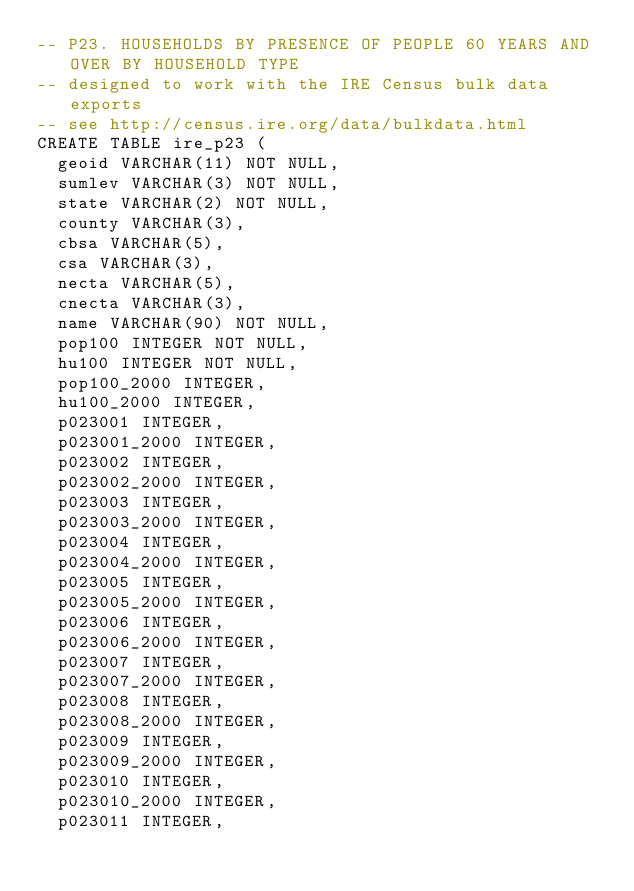<code> <loc_0><loc_0><loc_500><loc_500><_SQL_>-- P23. HOUSEHOLDS BY PRESENCE OF PEOPLE 60 YEARS AND OVER BY HOUSEHOLD TYPE
-- designed to work with the IRE Census bulk data exports
-- see http://census.ire.org/data/bulkdata.html
CREATE TABLE ire_p23 (
	geoid VARCHAR(11) NOT NULL, 
	sumlev VARCHAR(3) NOT NULL, 
	state VARCHAR(2) NOT NULL, 
	county VARCHAR(3), 
	cbsa VARCHAR(5), 
	csa VARCHAR(3), 
	necta VARCHAR(5), 
	cnecta VARCHAR(3), 
	name VARCHAR(90) NOT NULL, 
	pop100 INTEGER NOT NULL, 
	hu100 INTEGER NOT NULL, 
	pop100_2000 INTEGER, 
	hu100_2000 INTEGER, 
	p023001 INTEGER, 
	p023001_2000 INTEGER, 
	p023002 INTEGER, 
	p023002_2000 INTEGER, 
	p023003 INTEGER, 
	p023003_2000 INTEGER, 
	p023004 INTEGER, 
	p023004_2000 INTEGER, 
	p023005 INTEGER, 
	p023005_2000 INTEGER, 
	p023006 INTEGER, 
	p023006_2000 INTEGER, 
	p023007 INTEGER, 
	p023007_2000 INTEGER, 
	p023008 INTEGER, 
	p023008_2000 INTEGER, 
	p023009 INTEGER, 
	p023009_2000 INTEGER, 
	p023010 INTEGER, 
	p023010_2000 INTEGER, 
	p023011 INTEGER, </code> 